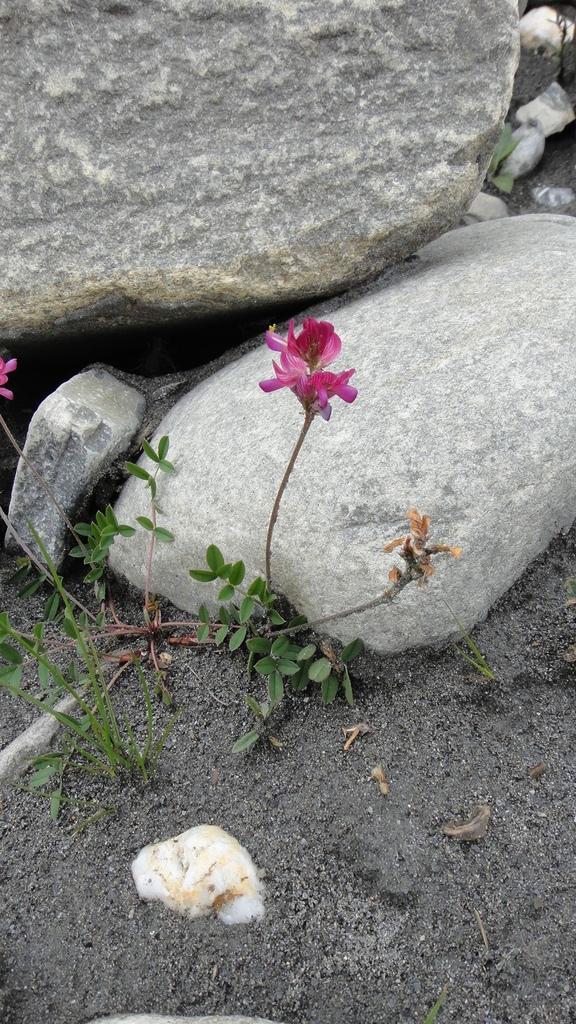Can you describe this image briefly? In the middle of this image, there is a plant having pink color flower and green color leaves. Besides this plant, there are grass and a stone. In the background, there are rocks on the ground. 